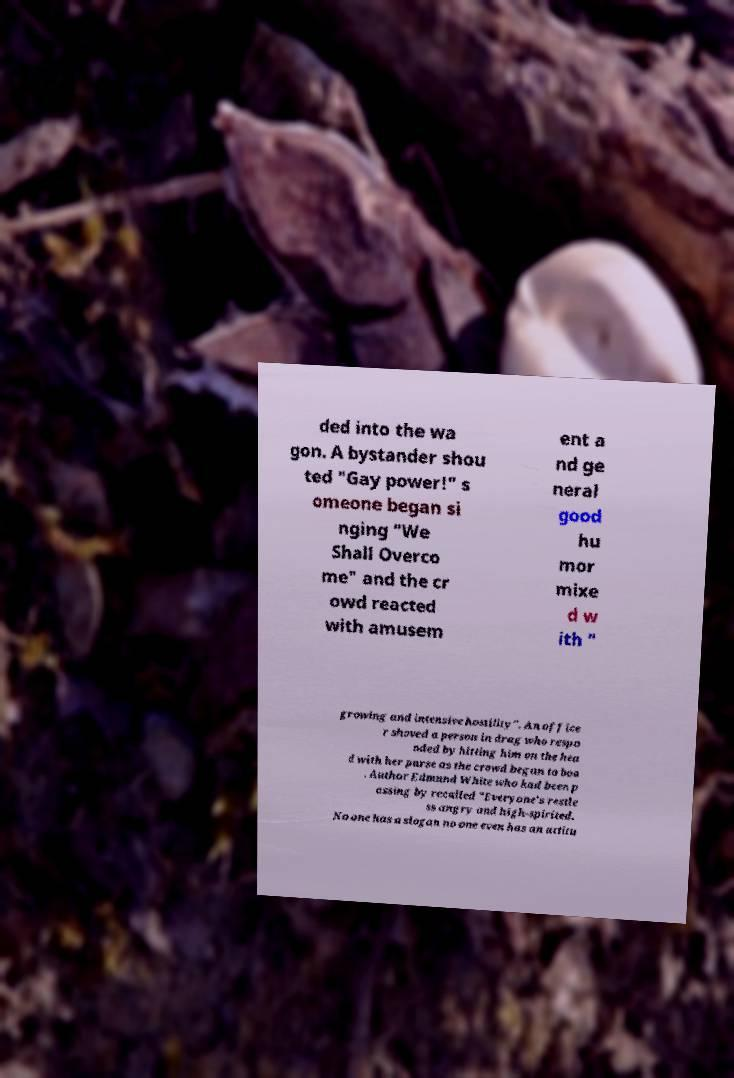Please identify and transcribe the text found in this image. ded into the wa gon. A bystander shou ted "Gay power!" s omeone began si nging "We Shall Overco me" and the cr owd reacted with amusem ent a nd ge neral good hu mor mixe d w ith " growing and intensive hostility". An office r shoved a person in drag who respo nded by hitting him on the hea d with her purse as the crowd began to boo . Author Edmund White who had been p assing by recalled "Everyone's restle ss angry and high-spirited. No one has a slogan no one even has an attitu 